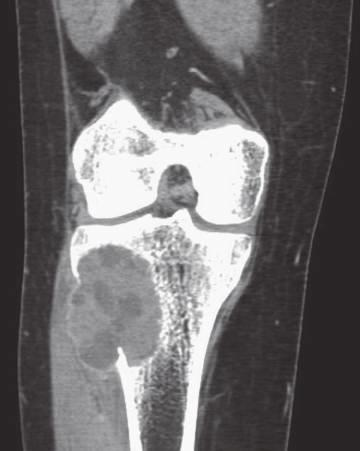s the soft tissue component delineated by a thin rim of reactive subperiosteal bone?
Answer the question using a single word or phrase. Yes 